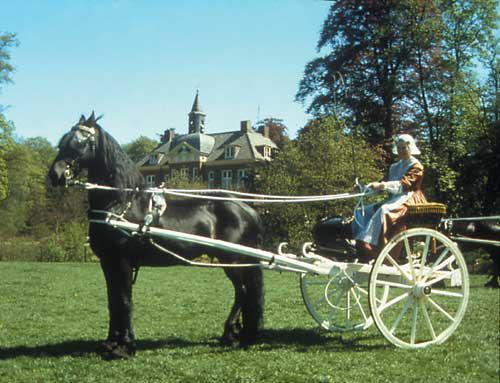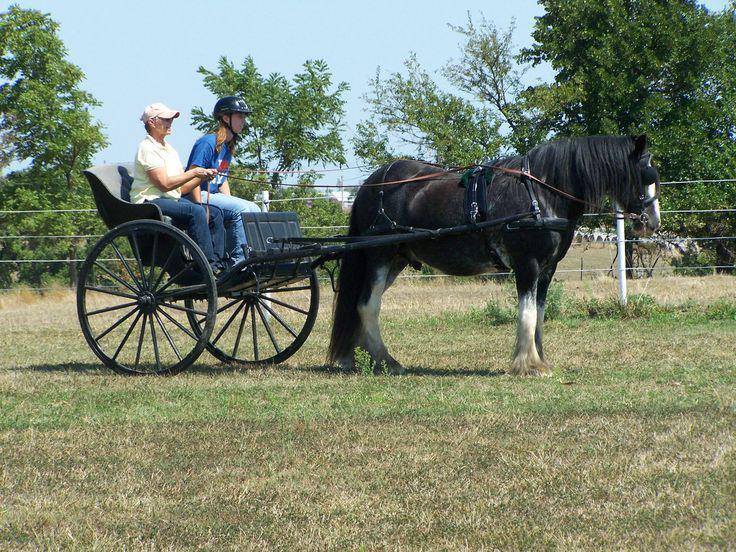The first image is the image on the left, the second image is the image on the right. Analyze the images presented: Is the assertion "There is no more than one person in the left image." valid? Answer yes or no. Yes. The first image is the image on the left, the second image is the image on the right. For the images displayed, is the sentence "All of the carts are being pulled by horses and none of the horses is being ridden by a person." factually correct? Answer yes or no. Yes. 